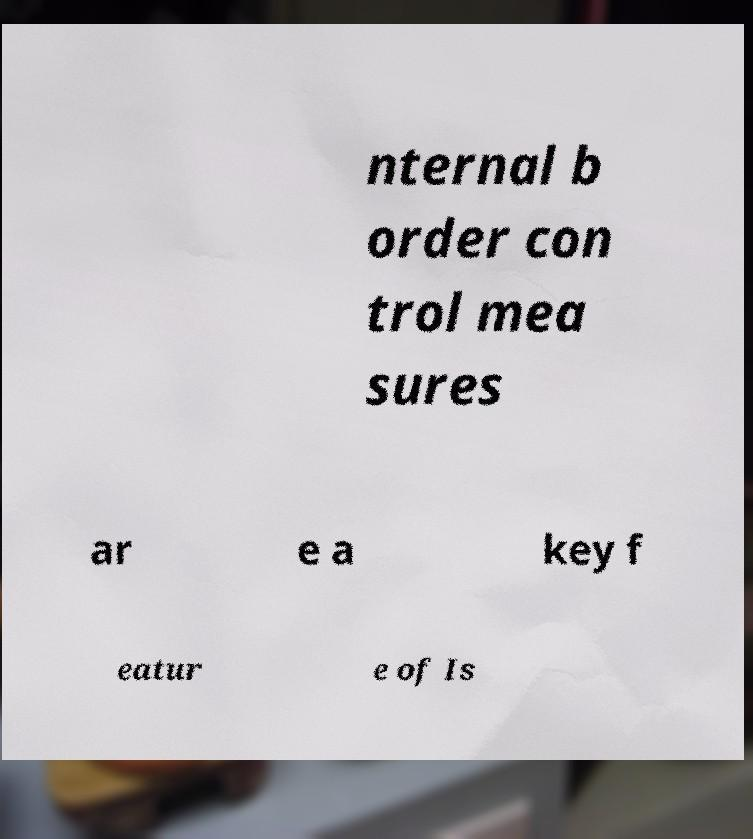Could you extract and type out the text from this image? nternal b order con trol mea sures ar e a key f eatur e of Is 